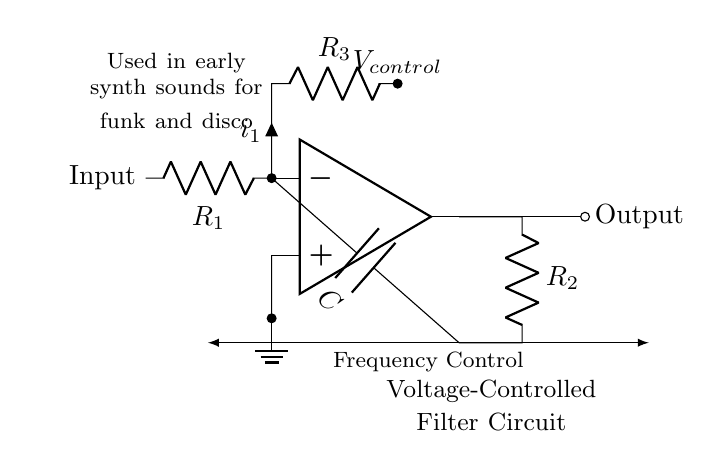What is the main function of this circuit? The circuit is designed as a voltage-controlled filter, which alters the frequency response based on the control voltage applied. This is essential in shaping the sound characteristics of early synthesizers.
Answer: voltage-controlled filter What do the resistors R1 and R2 represent? Resistor R1 is the input resistor that influences the gain and input impedance, while R2 forms a feedback loop with the capacitor C, affecting the filter characteristics.
Answer: input and feedback resistors What is the role of the capacitor C in this circuit? The capacitor C works in conjunction with the resistors to determine the cutoff frequency of the filter, affecting how frequencies are attenuated or passed through the output.
Answer: determines cutoff frequency What does the variable V_control denote? V_control indicates the control voltage input that adjusts the resistance of R3, impacting the performance of the voltage-controlled filter and its frequency response.
Answer: control voltage input In which music genres was this circuit primarily used? This circuit type was primarily used in funk and disco music, providing characteristic sounds that define the genres.
Answer: funk and disco How does the value of R3 affect the circuit? The value of R3, in conjunction with V_control, alters the filter’s frequency response by changing the resistance seen by the op-amp, affecting the overall sound character.
Answer: alters frequency response What type of operational amplifier is used in this circuit? The circuit employs a standard op-amp configuration to facilitate the amplification and feedback required for the filter function.
Answer: standard op-amp 